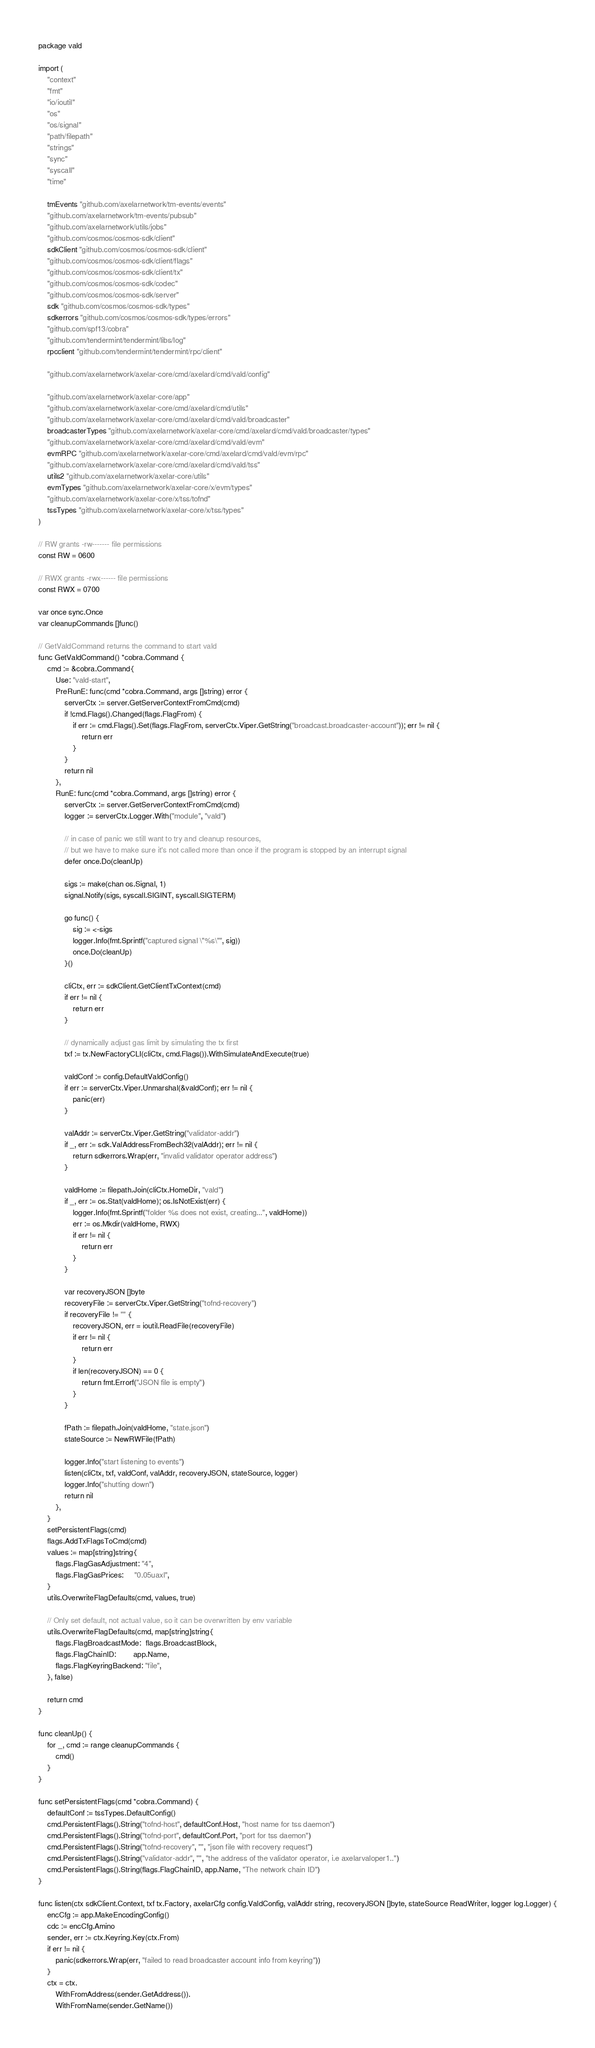<code> <loc_0><loc_0><loc_500><loc_500><_Go_>package vald

import (
	"context"
	"fmt"
	"io/ioutil"
	"os"
	"os/signal"
	"path/filepath"
	"strings"
	"sync"
	"syscall"
	"time"

	tmEvents "github.com/axelarnetwork/tm-events/events"
	"github.com/axelarnetwork/tm-events/pubsub"
	"github.com/axelarnetwork/utils/jobs"
	"github.com/cosmos/cosmos-sdk/client"
	sdkClient "github.com/cosmos/cosmos-sdk/client"
	"github.com/cosmos/cosmos-sdk/client/flags"
	"github.com/cosmos/cosmos-sdk/client/tx"
	"github.com/cosmos/cosmos-sdk/codec"
	"github.com/cosmos/cosmos-sdk/server"
	sdk "github.com/cosmos/cosmos-sdk/types"
	sdkerrors "github.com/cosmos/cosmos-sdk/types/errors"
	"github.com/spf13/cobra"
	"github.com/tendermint/tendermint/libs/log"
	rpcclient "github.com/tendermint/tendermint/rpc/client"

	"github.com/axelarnetwork/axelar-core/cmd/axelard/cmd/vald/config"

	"github.com/axelarnetwork/axelar-core/app"
	"github.com/axelarnetwork/axelar-core/cmd/axelard/cmd/utils"
	"github.com/axelarnetwork/axelar-core/cmd/axelard/cmd/vald/broadcaster"
	broadcasterTypes "github.com/axelarnetwork/axelar-core/cmd/axelard/cmd/vald/broadcaster/types"
	"github.com/axelarnetwork/axelar-core/cmd/axelard/cmd/vald/evm"
	evmRPC "github.com/axelarnetwork/axelar-core/cmd/axelard/cmd/vald/evm/rpc"
	"github.com/axelarnetwork/axelar-core/cmd/axelard/cmd/vald/tss"
	utils2 "github.com/axelarnetwork/axelar-core/utils"
	evmTypes "github.com/axelarnetwork/axelar-core/x/evm/types"
	"github.com/axelarnetwork/axelar-core/x/tss/tofnd"
	tssTypes "github.com/axelarnetwork/axelar-core/x/tss/types"
)

// RW grants -rw------- file permissions
const RW = 0600

// RWX grants -rwx------ file permissions
const RWX = 0700

var once sync.Once
var cleanupCommands []func()

// GetValdCommand returns the command to start vald
func GetValdCommand() *cobra.Command {
	cmd := &cobra.Command{
		Use: "vald-start",
		PreRunE: func(cmd *cobra.Command, args []string) error {
			serverCtx := server.GetServerContextFromCmd(cmd)
			if !cmd.Flags().Changed(flags.FlagFrom) {
				if err := cmd.Flags().Set(flags.FlagFrom, serverCtx.Viper.GetString("broadcast.broadcaster-account")); err != nil {
					return err
				}
			}
			return nil
		},
		RunE: func(cmd *cobra.Command, args []string) error {
			serverCtx := server.GetServerContextFromCmd(cmd)
			logger := serverCtx.Logger.With("module", "vald")

			// in case of panic we still want to try and cleanup resources,
			// but we have to make sure it's not called more than once if the program is stopped by an interrupt signal
			defer once.Do(cleanUp)

			sigs := make(chan os.Signal, 1)
			signal.Notify(sigs, syscall.SIGINT, syscall.SIGTERM)

			go func() {
				sig := <-sigs
				logger.Info(fmt.Sprintf("captured signal \"%s\"", sig))
				once.Do(cleanUp)
			}()

			cliCtx, err := sdkClient.GetClientTxContext(cmd)
			if err != nil {
				return err
			}

			// dynamically adjust gas limit by simulating the tx first
			txf := tx.NewFactoryCLI(cliCtx, cmd.Flags()).WithSimulateAndExecute(true)

			valdConf := config.DefaultValdConfig()
			if err := serverCtx.Viper.Unmarshal(&valdConf); err != nil {
				panic(err)
			}

			valAddr := serverCtx.Viper.GetString("validator-addr")
			if _, err := sdk.ValAddressFromBech32(valAddr); err != nil {
				return sdkerrors.Wrap(err, "invalid validator operator address")
			}

			valdHome := filepath.Join(cliCtx.HomeDir, "vald")
			if _, err := os.Stat(valdHome); os.IsNotExist(err) {
				logger.Info(fmt.Sprintf("folder %s does not exist, creating...", valdHome))
				err := os.Mkdir(valdHome, RWX)
				if err != nil {
					return err
				}
			}

			var recoveryJSON []byte
			recoveryFile := serverCtx.Viper.GetString("tofnd-recovery")
			if recoveryFile != "" {
				recoveryJSON, err = ioutil.ReadFile(recoveryFile)
				if err != nil {
					return err
				}
				if len(recoveryJSON) == 0 {
					return fmt.Errorf("JSON file is empty")
				}
			}

			fPath := filepath.Join(valdHome, "state.json")
			stateSource := NewRWFile(fPath)

			logger.Info("start listening to events")
			listen(cliCtx, txf, valdConf, valAddr, recoveryJSON, stateSource, logger)
			logger.Info("shutting down")
			return nil
		},
	}
	setPersistentFlags(cmd)
	flags.AddTxFlagsToCmd(cmd)
	values := map[string]string{
		flags.FlagGasAdjustment: "4",
		flags.FlagGasPrices:     "0.05uaxl",
	}
	utils.OverwriteFlagDefaults(cmd, values, true)

	// Only set default, not actual value, so it can be overwritten by env variable
	utils.OverwriteFlagDefaults(cmd, map[string]string{
		flags.FlagBroadcastMode:  flags.BroadcastBlock,
		flags.FlagChainID:        app.Name,
		flags.FlagKeyringBackend: "file",
	}, false)

	return cmd
}

func cleanUp() {
	for _, cmd := range cleanupCommands {
		cmd()
	}
}

func setPersistentFlags(cmd *cobra.Command) {
	defaultConf := tssTypes.DefaultConfig()
	cmd.PersistentFlags().String("tofnd-host", defaultConf.Host, "host name for tss daemon")
	cmd.PersistentFlags().String("tofnd-port", defaultConf.Port, "port for tss daemon")
	cmd.PersistentFlags().String("tofnd-recovery", "", "json file with recovery request")
	cmd.PersistentFlags().String("validator-addr", "", "the address of the validator operator, i.e axelarvaloper1..")
	cmd.PersistentFlags().String(flags.FlagChainID, app.Name, "The network chain ID")
}

func listen(ctx sdkClient.Context, txf tx.Factory, axelarCfg config.ValdConfig, valAddr string, recoveryJSON []byte, stateSource ReadWriter, logger log.Logger) {
	encCfg := app.MakeEncodingConfig()
	cdc := encCfg.Amino
	sender, err := ctx.Keyring.Key(ctx.From)
	if err != nil {
		panic(sdkerrors.Wrap(err, "failed to read broadcaster account info from keyring"))
	}
	ctx = ctx.
		WithFromAddress(sender.GetAddress()).
		WithFromName(sender.GetName())
</code> 